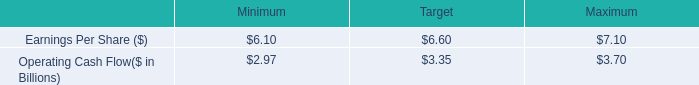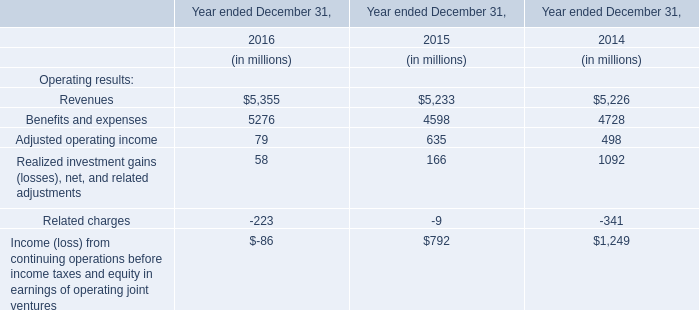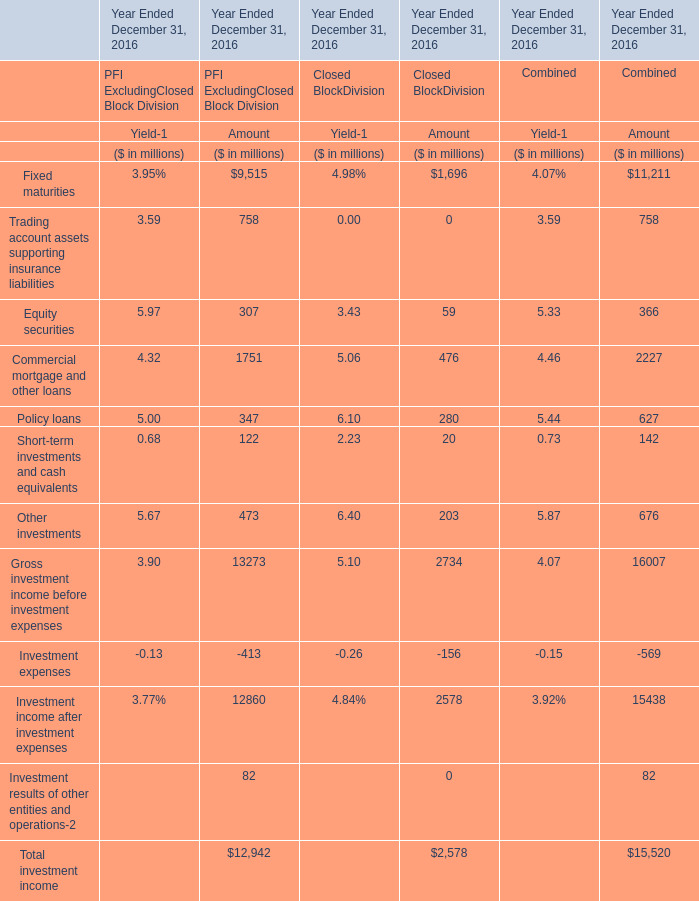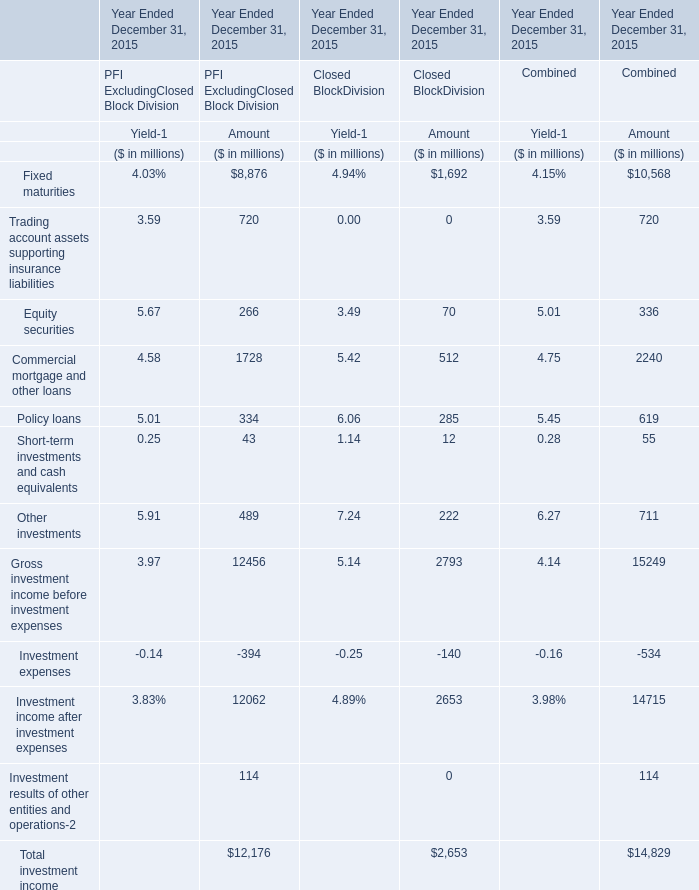Which section is Trading account assets supporting insurance liabilities the highest forPFI ExcludingClosed Block Division 
Answer: Amount. 